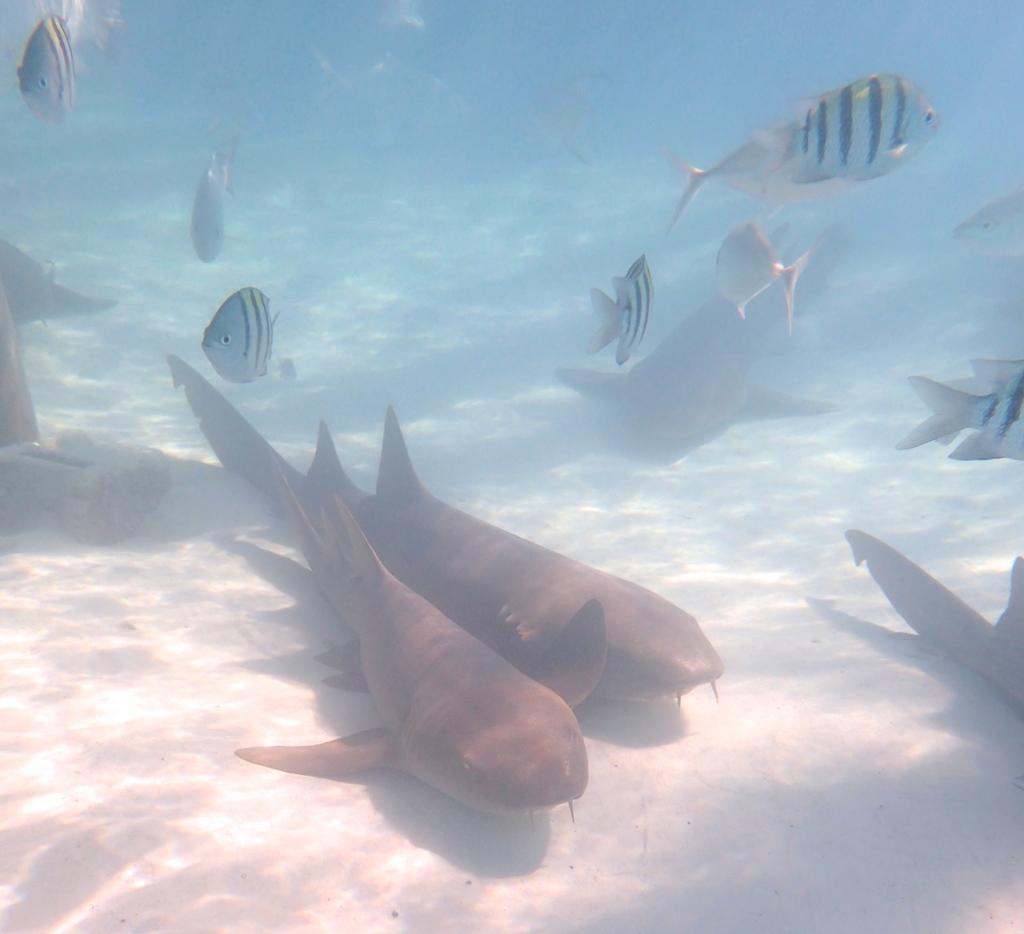Could you give a brief overview of what you see in this image? In this image we can see there are fish in the water. 